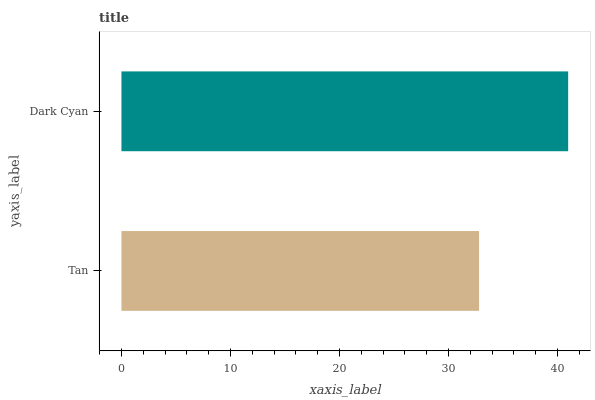Is Tan the minimum?
Answer yes or no. Yes. Is Dark Cyan the maximum?
Answer yes or no. Yes. Is Dark Cyan the minimum?
Answer yes or no. No. Is Dark Cyan greater than Tan?
Answer yes or no. Yes. Is Tan less than Dark Cyan?
Answer yes or no. Yes. Is Tan greater than Dark Cyan?
Answer yes or no. No. Is Dark Cyan less than Tan?
Answer yes or no. No. Is Dark Cyan the high median?
Answer yes or no. Yes. Is Tan the low median?
Answer yes or no. Yes. Is Tan the high median?
Answer yes or no. No. Is Dark Cyan the low median?
Answer yes or no. No. 